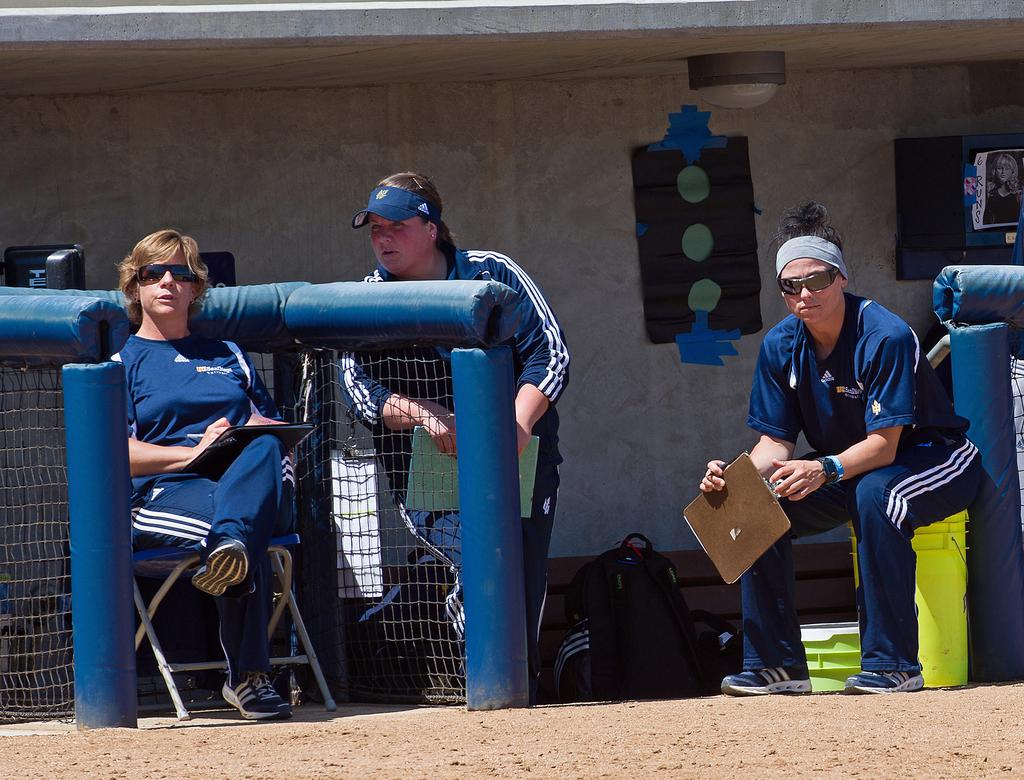What is the woman doing in the image? The woman is sitting on a chair on the left side of the image. What is the woman wearing in the image? The woman is wearing a blue dress in the image. Can you describe the other people present in the image? Unfortunately, the provided facts do not give any information about the other people present in the image. What is the woman's role in the ongoing war in the image? There is no mention of a war or any conflict in the image, so it is not possible to determine the woman's role in such a situation. 